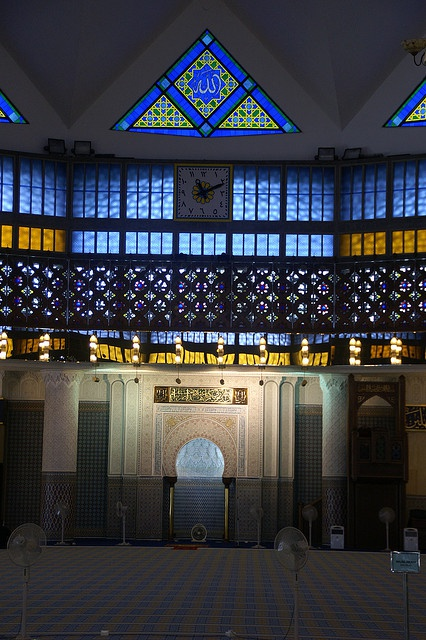Describe the objects in this image and their specific colors. I can see a clock in black tones in this image. 